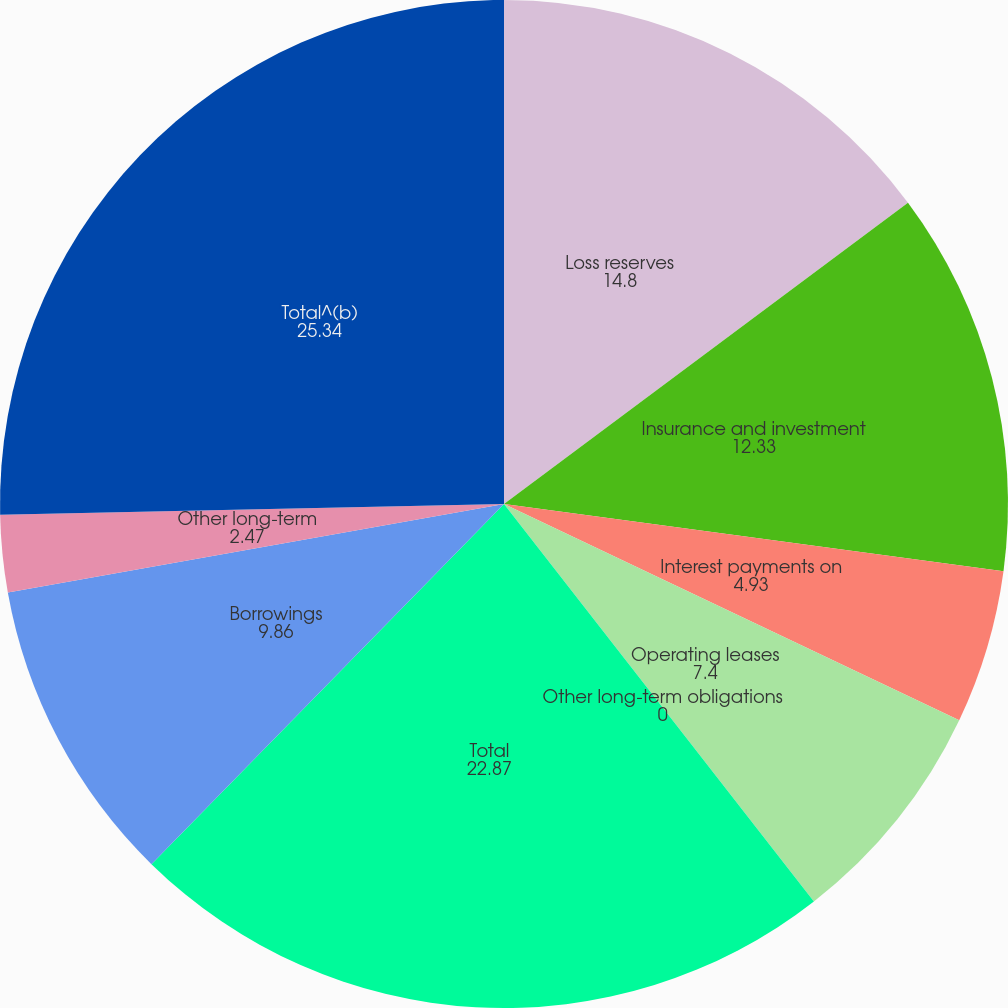Convert chart. <chart><loc_0><loc_0><loc_500><loc_500><pie_chart><fcel>Loss reserves<fcel>Insurance and investment<fcel>Interest payments on<fcel>Operating leases<fcel>Other long-term obligations<fcel>Total<fcel>Borrowings<fcel>Other long-term<fcel>Total^(b)<nl><fcel>14.8%<fcel>12.33%<fcel>4.93%<fcel>7.4%<fcel>0.0%<fcel>22.87%<fcel>9.86%<fcel>2.47%<fcel>25.34%<nl></chart> 